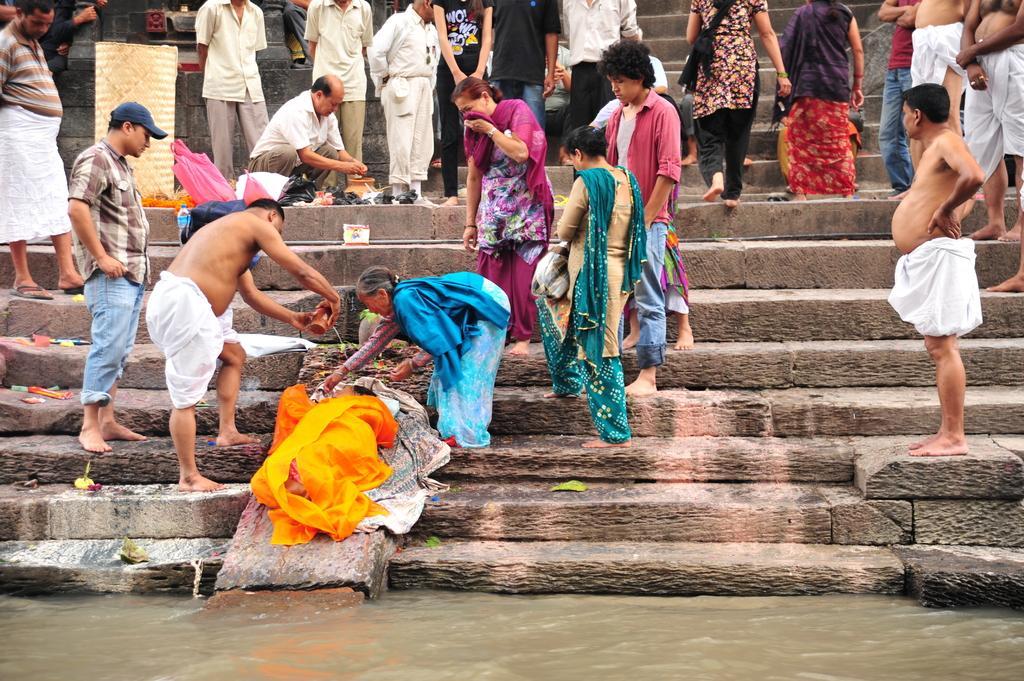Could you give a brief overview of what you see in this image? In this picture, we can see a few people, and a few are holding some objects stairs, water, and we can see some objects like cloth, bags, bottle. 